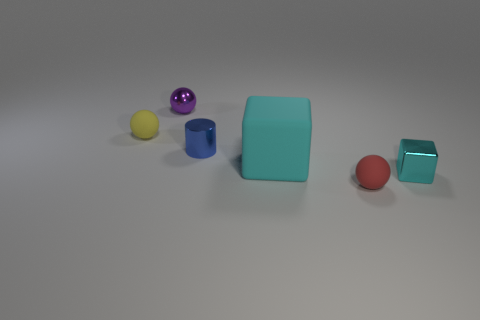There is another block that is the same color as the large block; what size is it?
Ensure brevity in your answer.  Small. Are there any red objects made of the same material as the cylinder?
Make the answer very short. No. Are there the same number of small blue metallic objects left of the purple shiny thing and small objects to the left of the big cyan block?
Your answer should be very brief. No. There is a matte ball that is in front of the tiny cyan shiny object; what is its size?
Provide a succinct answer. Small. The cube that is to the left of the matte thing that is to the right of the cyan matte thing is made of what material?
Provide a short and direct response. Rubber. What number of tiny cyan metal things are in front of the cyan object to the right of the sphere that is in front of the metallic cube?
Provide a succinct answer. 0. Is the material of the cyan block that is to the right of the matte cube the same as the cube that is on the left side of the small red rubber object?
Your answer should be compact. No. There is another small block that is the same color as the matte block; what material is it?
Your answer should be compact. Metal. What number of red things are the same shape as the purple shiny thing?
Ensure brevity in your answer.  1. Are there more red balls in front of the large rubber cube than tiny green shiny cubes?
Provide a short and direct response. Yes. 